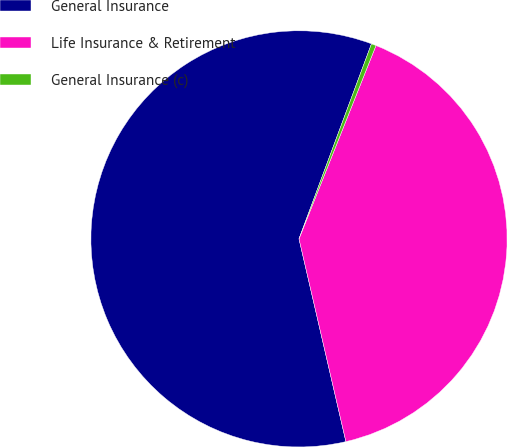Convert chart. <chart><loc_0><loc_0><loc_500><loc_500><pie_chart><fcel>General Insurance<fcel>Life Insurance & Retirement<fcel>General Insurance (c)<nl><fcel>59.28%<fcel>40.35%<fcel>0.37%<nl></chart> 